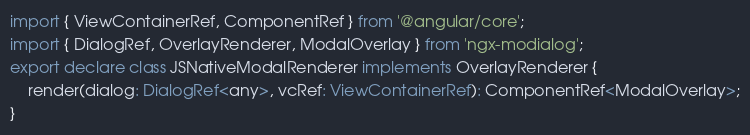<code> <loc_0><loc_0><loc_500><loc_500><_TypeScript_>import { ViewContainerRef, ComponentRef } from '@angular/core';
import { DialogRef, OverlayRenderer, ModalOverlay } from 'ngx-modialog';
export declare class JSNativeModalRenderer implements OverlayRenderer {
    render(dialog: DialogRef<any>, vcRef: ViewContainerRef): ComponentRef<ModalOverlay>;
}
</code> 